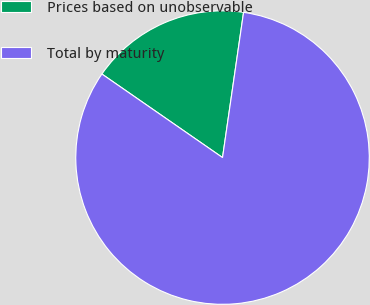Convert chart. <chart><loc_0><loc_0><loc_500><loc_500><pie_chart><fcel>Prices based on unobservable<fcel>Total by maturity<nl><fcel>17.65%<fcel>82.35%<nl></chart> 